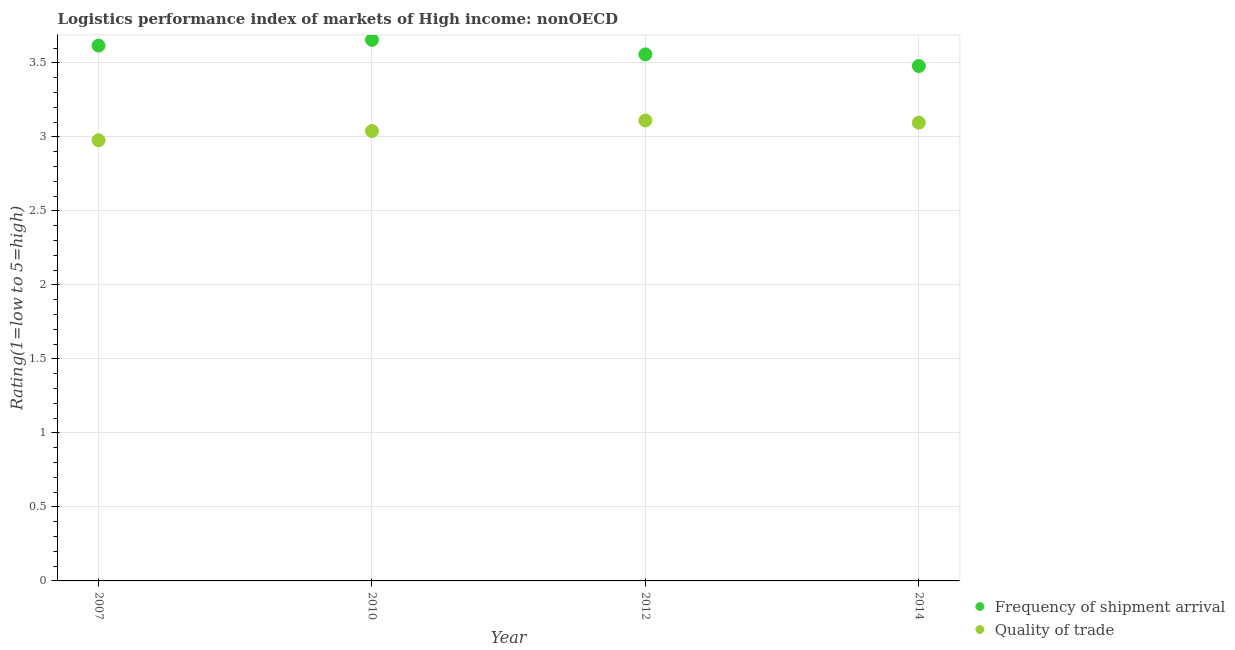How many different coloured dotlines are there?
Your answer should be very brief. 2. What is the lpi of frequency of shipment arrival in 2014?
Provide a short and direct response. 3.48. Across all years, what is the maximum lpi quality of trade?
Your answer should be compact. 3.11. Across all years, what is the minimum lpi quality of trade?
Offer a very short reply. 2.98. In which year was the lpi of frequency of shipment arrival minimum?
Your answer should be very brief. 2014. What is the total lpi of frequency of shipment arrival in the graph?
Your answer should be compact. 14.31. What is the difference between the lpi of frequency of shipment arrival in 2010 and that in 2012?
Give a very brief answer. 0.1. What is the difference between the lpi quality of trade in 2007 and the lpi of frequency of shipment arrival in 2014?
Your answer should be very brief. -0.5. What is the average lpi of frequency of shipment arrival per year?
Keep it short and to the point. 3.58. In the year 2010, what is the difference between the lpi of frequency of shipment arrival and lpi quality of trade?
Keep it short and to the point. 0.62. In how many years, is the lpi quality of trade greater than 3.1?
Offer a terse response. 1. What is the ratio of the lpi quality of trade in 2007 to that in 2014?
Offer a terse response. 0.96. Is the difference between the lpi quality of trade in 2010 and 2014 greater than the difference between the lpi of frequency of shipment arrival in 2010 and 2014?
Provide a short and direct response. No. What is the difference between the highest and the second highest lpi of frequency of shipment arrival?
Provide a short and direct response. 0.04. What is the difference between the highest and the lowest lpi of frequency of shipment arrival?
Your answer should be compact. 0.18. In how many years, is the lpi of frequency of shipment arrival greater than the average lpi of frequency of shipment arrival taken over all years?
Offer a terse response. 2. Is the sum of the lpi of frequency of shipment arrival in 2012 and 2014 greater than the maximum lpi quality of trade across all years?
Offer a terse response. Yes. Does the lpi of frequency of shipment arrival monotonically increase over the years?
Ensure brevity in your answer.  No. Is the lpi quality of trade strictly less than the lpi of frequency of shipment arrival over the years?
Your answer should be very brief. Yes. How many dotlines are there?
Offer a terse response. 2. What is the difference between two consecutive major ticks on the Y-axis?
Your response must be concise. 0.5. Where does the legend appear in the graph?
Your response must be concise. Bottom right. What is the title of the graph?
Your answer should be compact. Logistics performance index of markets of High income: nonOECD. Does "Not attending school" appear as one of the legend labels in the graph?
Provide a succinct answer. No. What is the label or title of the X-axis?
Make the answer very short. Year. What is the label or title of the Y-axis?
Offer a very short reply. Rating(1=low to 5=high). What is the Rating(1=low to 5=high) in Frequency of shipment arrival in 2007?
Ensure brevity in your answer.  3.62. What is the Rating(1=low to 5=high) in Quality of trade in 2007?
Provide a short and direct response. 2.98. What is the Rating(1=low to 5=high) of Frequency of shipment arrival in 2010?
Provide a succinct answer. 3.66. What is the Rating(1=low to 5=high) in Quality of trade in 2010?
Make the answer very short. 3.04. What is the Rating(1=low to 5=high) in Frequency of shipment arrival in 2012?
Make the answer very short. 3.56. What is the Rating(1=low to 5=high) of Quality of trade in 2012?
Your answer should be very brief. 3.11. What is the Rating(1=low to 5=high) of Frequency of shipment arrival in 2014?
Offer a very short reply. 3.48. What is the Rating(1=low to 5=high) of Quality of trade in 2014?
Your answer should be very brief. 3.1. Across all years, what is the maximum Rating(1=low to 5=high) of Frequency of shipment arrival?
Provide a succinct answer. 3.66. Across all years, what is the maximum Rating(1=low to 5=high) of Quality of trade?
Your answer should be very brief. 3.11. Across all years, what is the minimum Rating(1=low to 5=high) in Frequency of shipment arrival?
Make the answer very short. 3.48. Across all years, what is the minimum Rating(1=low to 5=high) in Quality of trade?
Make the answer very short. 2.98. What is the total Rating(1=low to 5=high) in Frequency of shipment arrival in the graph?
Keep it short and to the point. 14.31. What is the total Rating(1=low to 5=high) in Quality of trade in the graph?
Give a very brief answer. 12.23. What is the difference between the Rating(1=low to 5=high) in Frequency of shipment arrival in 2007 and that in 2010?
Your response must be concise. -0.04. What is the difference between the Rating(1=low to 5=high) of Quality of trade in 2007 and that in 2010?
Provide a short and direct response. -0.06. What is the difference between the Rating(1=low to 5=high) in Frequency of shipment arrival in 2007 and that in 2012?
Offer a terse response. 0.06. What is the difference between the Rating(1=low to 5=high) in Quality of trade in 2007 and that in 2012?
Your response must be concise. -0.13. What is the difference between the Rating(1=low to 5=high) in Frequency of shipment arrival in 2007 and that in 2014?
Keep it short and to the point. 0.14. What is the difference between the Rating(1=low to 5=high) of Quality of trade in 2007 and that in 2014?
Make the answer very short. -0.12. What is the difference between the Rating(1=low to 5=high) of Frequency of shipment arrival in 2010 and that in 2012?
Offer a very short reply. 0.1. What is the difference between the Rating(1=low to 5=high) of Quality of trade in 2010 and that in 2012?
Offer a terse response. -0.07. What is the difference between the Rating(1=low to 5=high) in Frequency of shipment arrival in 2010 and that in 2014?
Ensure brevity in your answer.  0.18. What is the difference between the Rating(1=low to 5=high) in Quality of trade in 2010 and that in 2014?
Your answer should be compact. -0.06. What is the difference between the Rating(1=low to 5=high) in Frequency of shipment arrival in 2012 and that in 2014?
Your answer should be very brief. 0.08. What is the difference between the Rating(1=low to 5=high) of Quality of trade in 2012 and that in 2014?
Offer a terse response. 0.01. What is the difference between the Rating(1=low to 5=high) of Frequency of shipment arrival in 2007 and the Rating(1=low to 5=high) of Quality of trade in 2010?
Your answer should be compact. 0.58. What is the difference between the Rating(1=low to 5=high) of Frequency of shipment arrival in 2007 and the Rating(1=low to 5=high) of Quality of trade in 2012?
Your response must be concise. 0.51. What is the difference between the Rating(1=low to 5=high) in Frequency of shipment arrival in 2007 and the Rating(1=low to 5=high) in Quality of trade in 2014?
Provide a succinct answer. 0.52. What is the difference between the Rating(1=low to 5=high) of Frequency of shipment arrival in 2010 and the Rating(1=low to 5=high) of Quality of trade in 2012?
Provide a short and direct response. 0.54. What is the difference between the Rating(1=low to 5=high) in Frequency of shipment arrival in 2010 and the Rating(1=low to 5=high) in Quality of trade in 2014?
Your answer should be compact. 0.56. What is the difference between the Rating(1=low to 5=high) of Frequency of shipment arrival in 2012 and the Rating(1=low to 5=high) of Quality of trade in 2014?
Offer a very short reply. 0.46. What is the average Rating(1=low to 5=high) of Frequency of shipment arrival per year?
Make the answer very short. 3.58. What is the average Rating(1=low to 5=high) in Quality of trade per year?
Provide a short and direct response. 3.06. In the year 2007, what is the difference between the Rating(1=low to 5=high) of Frequency of shipment arrival and Rating(1=low to 5=high) of Quality of trade?
Your answer should be compact. 0.64. In the year 2010, what is the difference between the Rating(1=low to 5=high) of Frequency of shipment arrival and Rating(1=low to 5=high) of Quality of trade?
Give a very brief answer. 0.62. In the year 2012, what is the difference between the Rating(1=low to 5=high) of Frequency of shipment arrival and Rating(1=low to 5=high) of Quality of trade?
Your answer should be compact. 0.45. In the year 2014, what is the difference between the Rating(1=low to 5=high) of Frequency of shipment arrival and Rating(1=low to 5=high) of Quality of trade?
Provide a succinct answer. 0.38. What is the ratio of the Rating(1=low to 5=high) of Quality of trade in 2007 to that in 2010?
Your response must be concise. 0.98. What is the ratio of the Rating(1=low to 5=high) in Frequency of shipment arrival in 2007 to that in 2012?
Your answer should be compact. 1.02. What is the ratio of the Rating(1=low to 5=high) of Quality of trade in 2007 to that in 2012?
Ensure brevity in your answer.  0.96. What is the ratio of the Rating(1=low to 5=high) in Frequency of shipment arrival in 2007 to that in 2014?
Offer a terse response. 1.04. What is the ratio of the Rating(1=low to 5=high) in Quality of trade in 2007 to that in 2014?
Provide a succinct answer. 0.96. What is the ratio of the Rating(1=low to 5=high) in Frequency of shipment arrival in 2010 to that in 2012?
Offer a very short reply. 1.03. What is the ratio of the Rating(1=low to 5=high) in Quality of trade in 2010 to that in 2012?
Keep it short and to the point. 0.98. What is the ratio of the Rating(1=low to 5=high) of Frequency of shipment arrival in 2010 to that in 2014?
Your response must be concise. 1.05. What is the ratio of the Rating(1=low to 5=high) of Quality of trade in 2010 to that in 2014?
Your answer should be very brief. 0.98. What is the ratio of the Rating(1=low to 5=high) in Frequency of shipment arrival in 2012 to that in 2014?
Make the answer very short. 1.02. What is the difference between the highest and the second highest Rating(1=low to 5=high) of Frequency of shipment arrival?
Provide a succinct answer. 0.04. What is the difference between the highest and the second highest Rating(1=low to 5=high) in Quality of trade?
Give a very brief answer. 0.01. What is the difference between the highest and the lowest Rating(1=low to 5=high) in Frequency of shipment arrival?
Ensure brevity in your answer.  0.18. What is the difference between the highest and the lowest Rating(1=low to 5=high) in Quality of trade?
Offer a terse response. 0.13. 